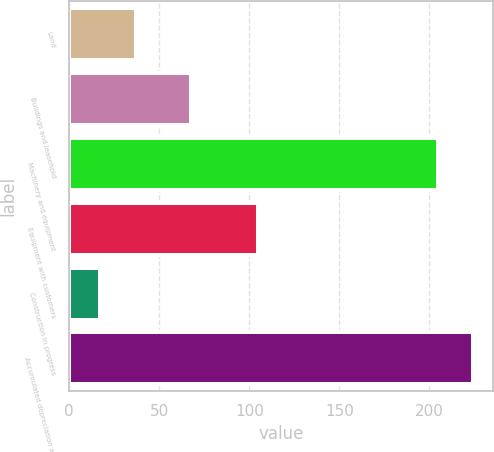Convert chart to OTSL. <chart><loc_0><loc_0><loc_500><loc_500><bar_chart><fcel>Land<fcel>Buildings and leasehold<fcel>Machinery and equipment<fcel>Equipment with customers<fcel>Construction in progress<fcel>Accumulated depreciation and<nl><fcel>36.9<fcel>67.4<fcel>204.6<fcel>104.8<fcel>17.2<fcel>224.3<nl></chart> 